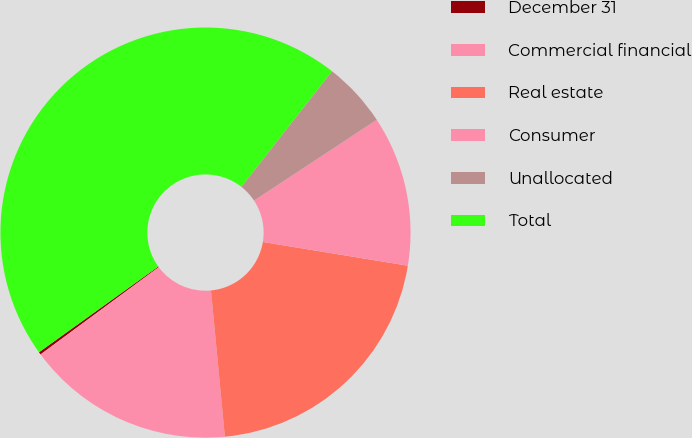Convert chart to OTSL. <chart><loc_0><loc_0><loc_500><loc_500><pie_chart><fcel>December 31<fcel>Commercial financial<fcel>Real estate<fcel>Consumer<fcel>Unallocated<fcel>Total<nl><fcel>0.21%<fcel>16.38%<fcel>20.91%<fcel>11.85%<fcel>5.15%<fcel>45.5%<nl></chart> 